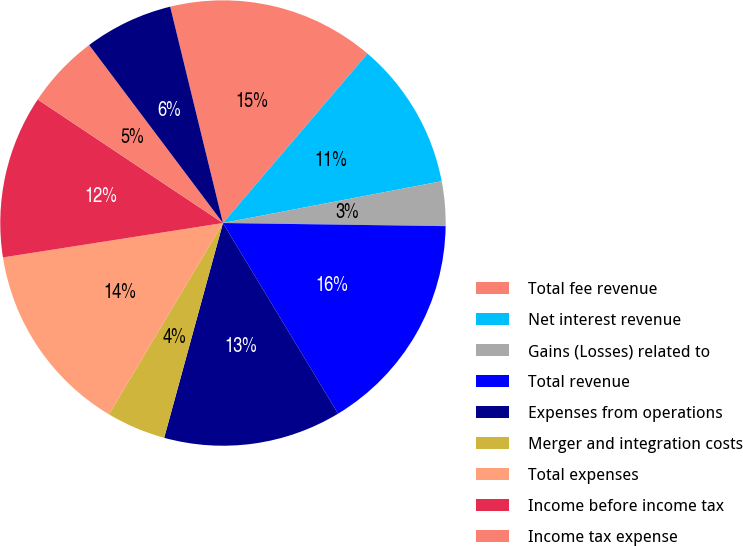Convert chart to OTSL. <chart><loc_0><loc_0><loc_500><loc_500><pie_chart><fcel>Total fee revenue<fcel>Net interest revenue<fcel>Gains (Losses) related to<fcel>Total revenue<fcel>Expenses from operations<fcel>Merger and integration costs<fcel>Total expenses<fcel>Income before income tax<fcel>Income tax expense<fcel>Income before extraordinary<nl><fcel>15.05%<fcel>10.75%<fcel>3.23%<fcel>16.13%<fcel>12.9%<fcel>4.3%<fcel>13.98%<fcel>11.83%<fcel>5.38%<fcel>6.45%<nl></chart> 